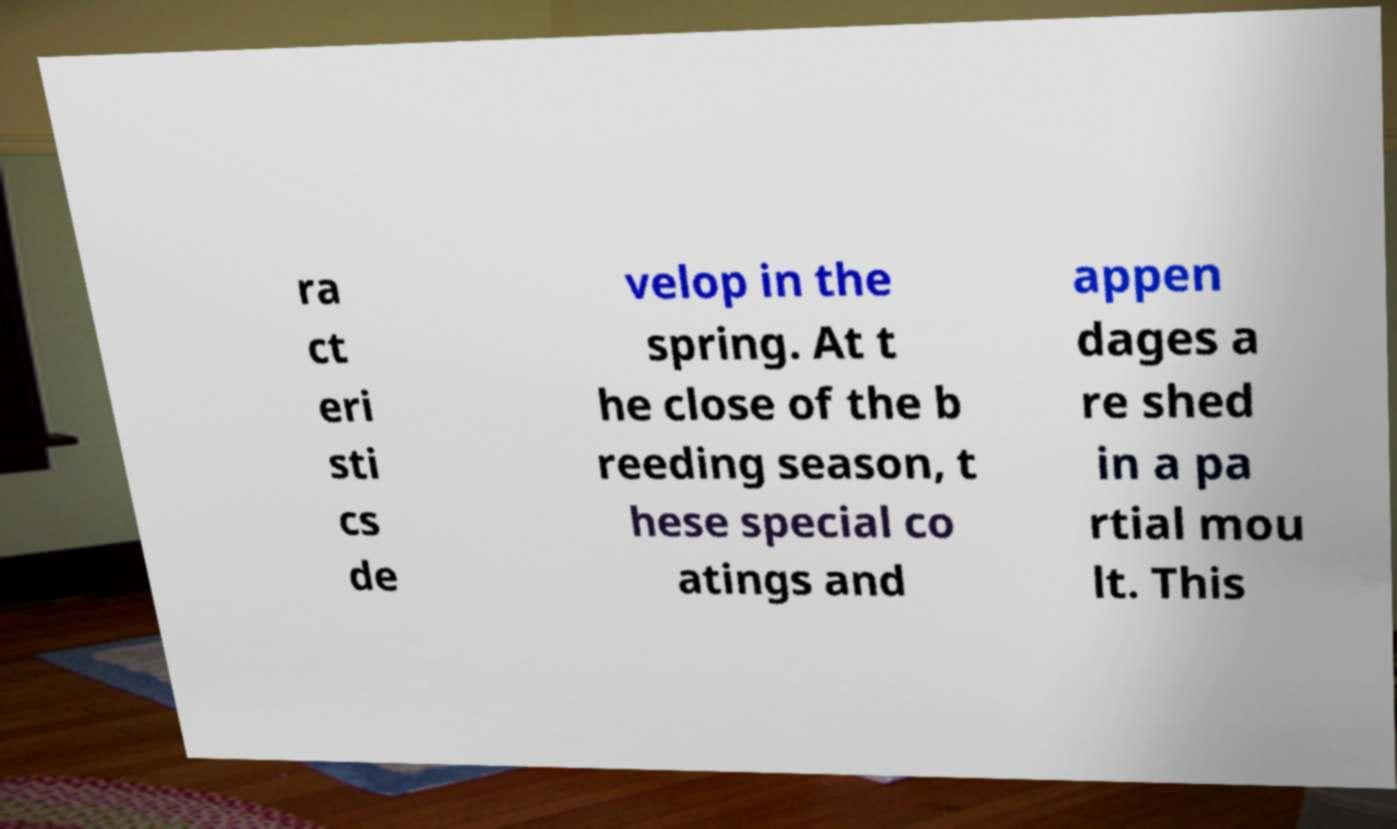For documentation purposes, I need the text within this image transcribed. Could you provide that? ra ct eri sti cs de velop in the spring. At t he close of the b reeding season, t hese special co atings and appen dages a re shed in a pa rtial mou lt. This 